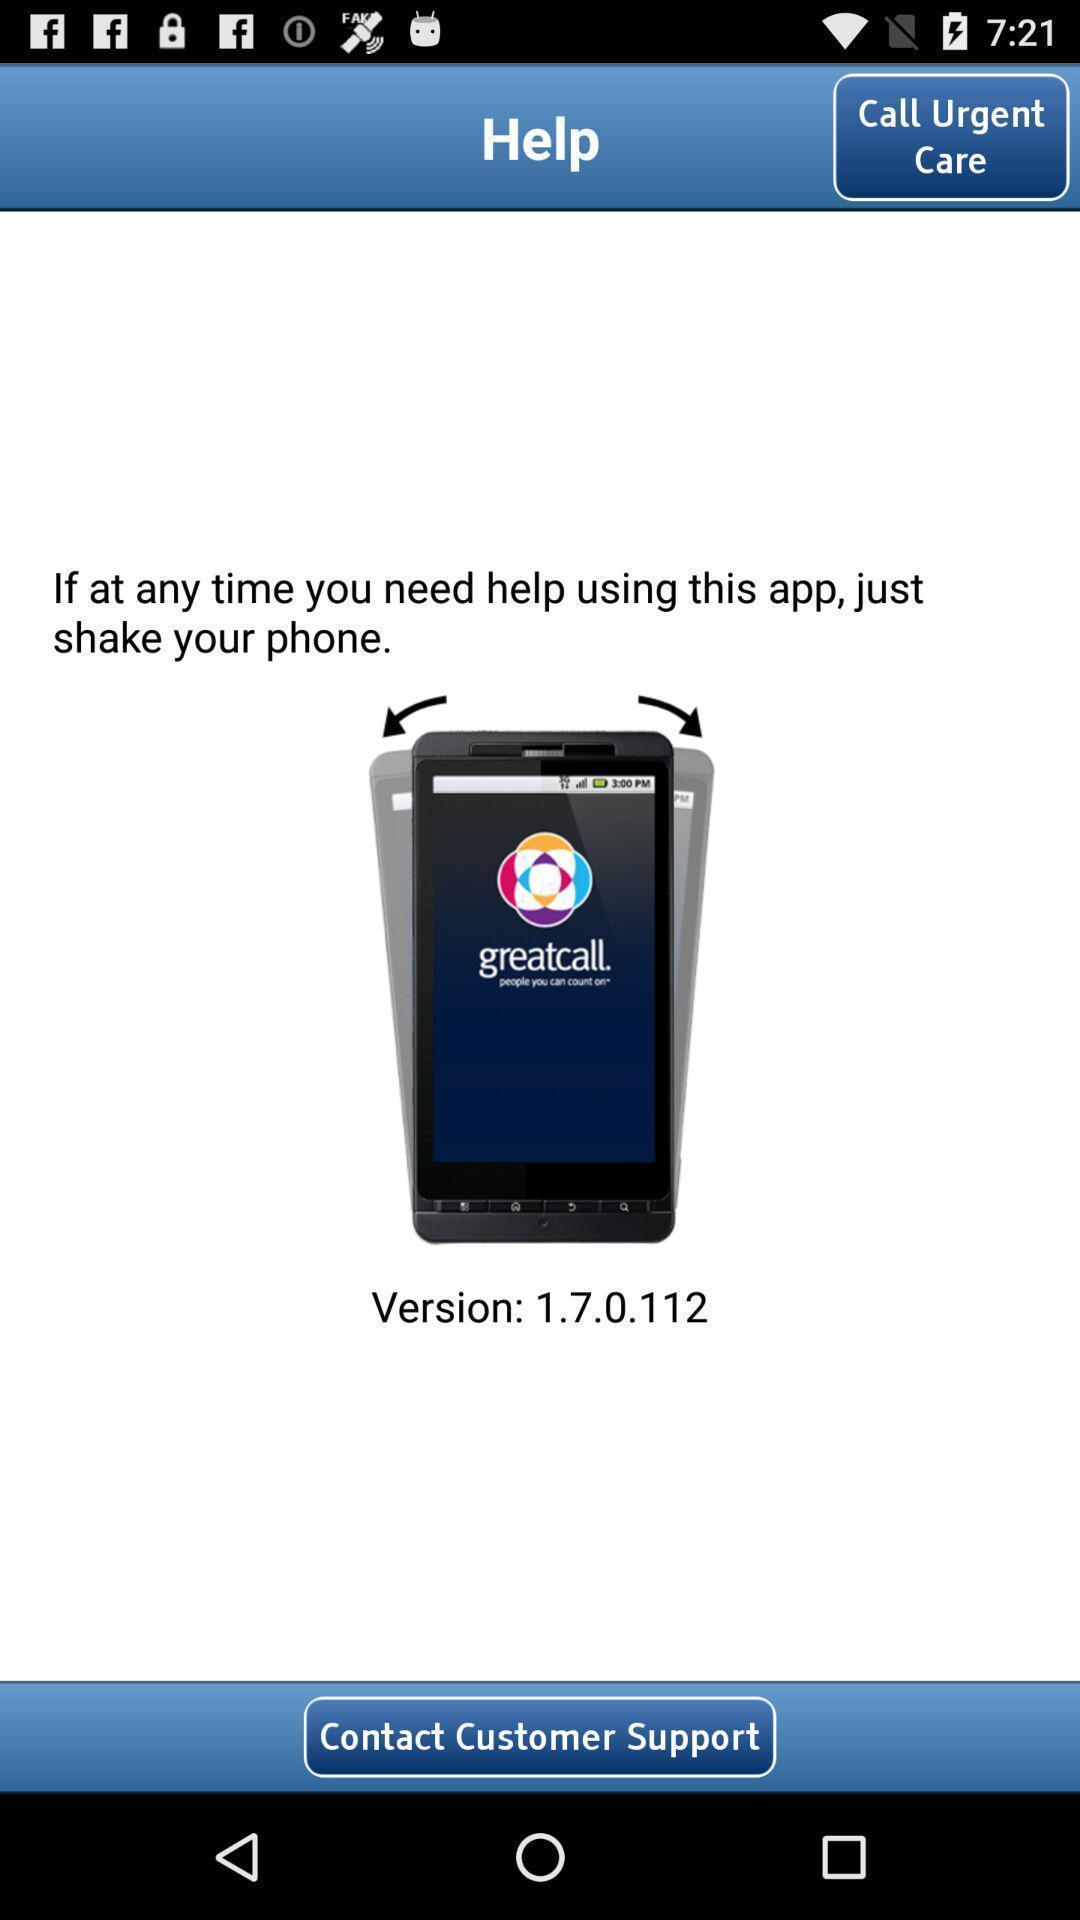Describe this image in words. Screen displaying guide for using an app. 